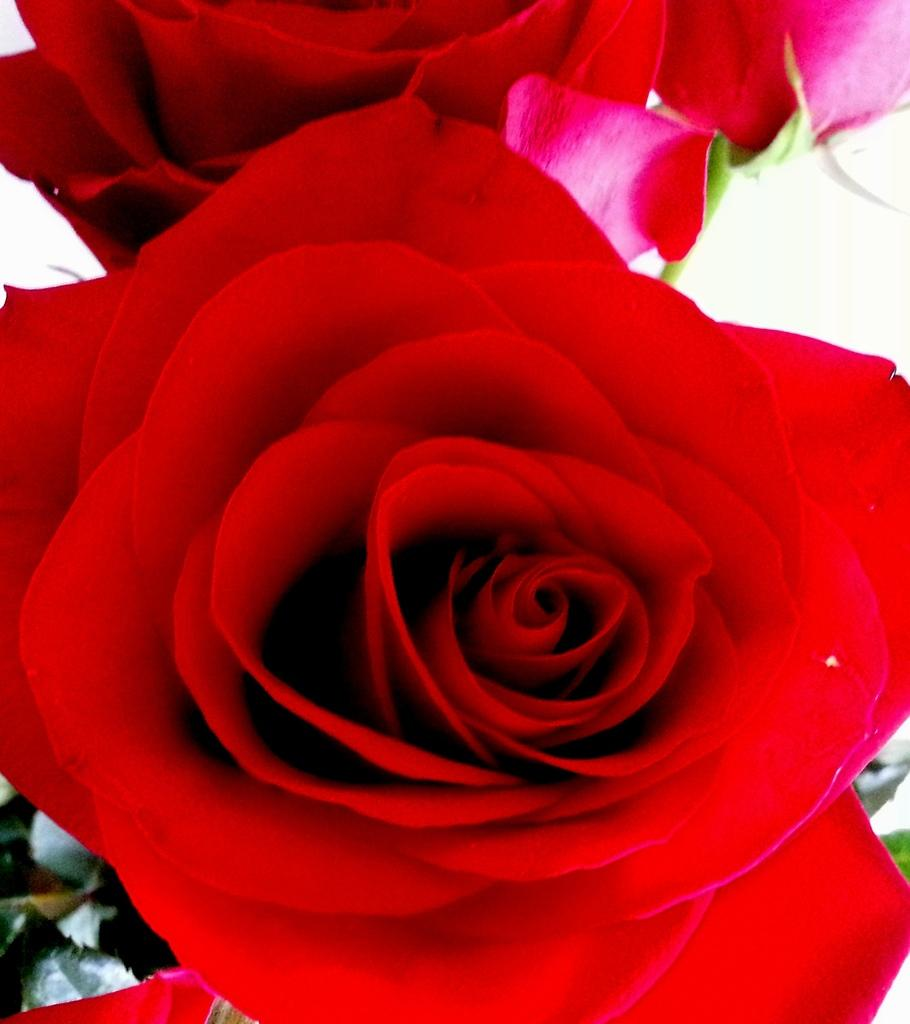What type of flowers are present in the image? There are two red roses in the image. What color is the background of the image? The background is white. Where can leaves be found in the image? A few leaves are visible in the bottom left-hand corner of the image. What type of belief is represented by the van in the image? There is no van present in the image, so it is not possible to determine what belief might be represented. 